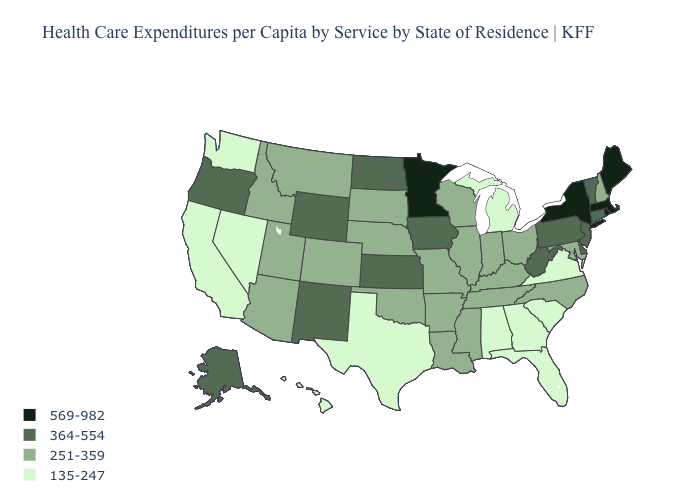What is the value of California?
Give a very brief answer. 135-247. Among the states that border Washington , which have the highest value?
Concise answer only. Oregon. Name the states that have a value in the range 569-982?
Give a very brief answer. Maine, Massachusetts, Minnesota, New York, Rhode Island. What is the value of South Dakota?
Write a very short answer. 251-359. What is the value of Louisiana?
Give a very brief answer. 251-359. What is the value of Illinois?
Concise answer only. 251-359. Does Texas have the lowest value in the USA?
Give a very brief answer. Yes. Name the states that have a value in the range 251-359?
Quick response, please. Arizona, Arkansas, Colorado, Idaho, Illinois, Indiana, Kentucky, Louisiana, Maryland, Mississippi, Missouri, Montana, Nebraska, New Hampshire, North Carolina, Ohio, Oklahoma, South Dakota, Tennessee, Utah, Wisconsin. What is the value of Iowa?
Quick response, please. 364-554. Name the states that have a value in the range 569-982?
Quick response, please. Maine, Massachusetts, Minnesota, New York, Rhode Island. What is the value of New York?
Answer briefly. 569-982. Name the states that have a value in the range 251-359?
Give a very brief answer. Arizona, Arkansas, Colorado, Idaho, Illinois, Indiana, Kentucky, Louisiana, Maryland, Mississippi, Missouri, Montana, Nebraska, New Hampshire, North Carolina, Ohio, Oklahoma, South Dakota, Tennessee, Utah, Wisconsin. Does New Jersey have a higher value than Montana?
Give a very brief answer. Yes. Does Colorado have a higher value than Oregon?
Be succinct. No. Which states have the highest value in the USA?
Write a very short answer. Maine, Massachusetts, Minnesota, New York, Rhode Island. 